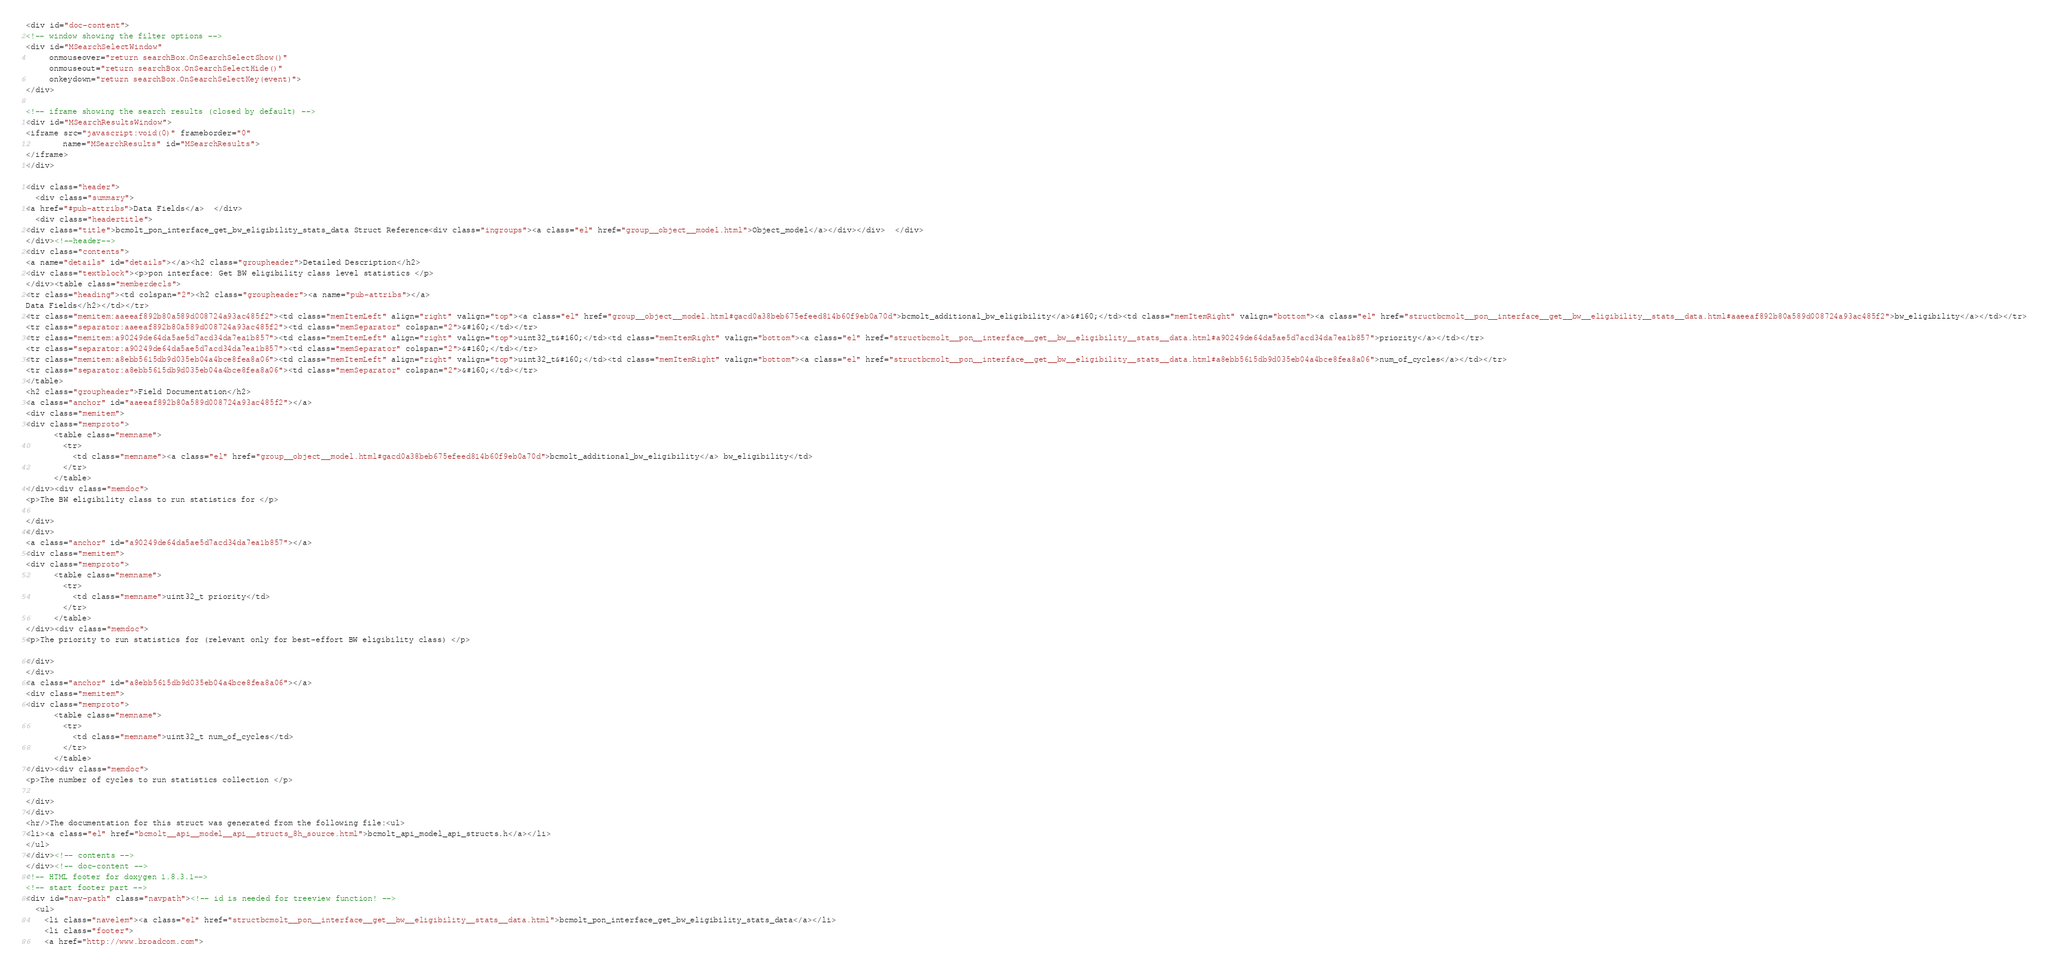<code> <loc_0><loc_0><loc_500><loc_500><_HTML_><div id="doc-content">
<!-- window showing the filter options -->
<div id="MSearchSelectWindow"
     onmouseover="return searchBox.OnSearchSelectShow()"
     onmouseout="return searchBox.OnSearchSelectHide()"
     onkeydown="return searchBox.OnSearchSelectKey(event)">
</div>

<!-- iframe showing the search results (closed by default) -->
<div id="MSearchResultsWindow">
<iframe src="javascript:void(0)" frameborder="0" 
        name="MSearchResults" id="MSearchResults">
</iframe>
</div>

<div class="header">
  <div class="summary">
<a href="#pub-attribs">Data Fields</a>  </div>
  <div class="headertitle">
<div class="title">bcmolt_pon_interface_get_bw_eligibility_stats_data Struct Reference<div class="ingroups"><a class="el" href="group__object__model.html">Object_model</a></div></div>  </div>
</div><!--header-->
<div class="contents">
<a name="details" id="details"></a><h2 class="groupheader">Detailed Description</h2>
<div class="textblock"><p>pon interface: Get BW eligibility class level statistics </p>
</div><table class="memberdecls">
<tr class="heading"><td colspan="2"><h2 class="groupheader"><a name="pub-attribs"></a>
Data Fields</h2></td></tr>
<tr class="memitem:aaeeaf892b80a589d008724a93ac485f2"><td class="memItemLeft" align="right" valign="top"><a class="el" href="group__object__model.html#gacd0a38beb675efeed814b60f9eb0a70d">bcmolt_additional_bw_eligibility</a>&#160;</td><td class="memItemRight" valign="bottom"><a class="el" href="structbcmolt__pon__interface__get__bw__eligibility__stats__data.html#aaeeaf892b80a589d008724a93ac485f2">bw_eligibility</a></td></tr>
<tr class="separator:aaeeaf892b80a589d008724a93ac485f2"><td class="memSeparator" colspan="2">&#160;</td></tr>
<tr class="memitem:a90249de64da5ae5d7acd34da7ea1b857"><td class="memItemLeft" align="right" valign="top">uint32_t&#160;</td><td class="memItemRight" valign="bottom"><a class="el" href="structbcmolt__pon__interface__get__bw__eligibility__stats__data.html#a90249de64da5ae5d7acd34da7ea1b857">priority</a></td></tr>
<tr class="separator:a90249de64da5ae5d7acd34da7ea1b857"><td class="memSeparator" colspan="2">&#160;</td></tr>
<tr class="memitem:a8ebb5615db9d035eb04a4bce8fea8a06"><td class="memItemLeft" align="right" valign="top">uint32_t&#160;</td><td class="memItemRight" valign="bottom"><a class="el" href="structbcmolt__pon__interface__get__bw__eligibility__stats__data.html#a8ebb5615db9d035eb04a4bce8fea8a06">num_of_cycles</a></td></tr>
<tr class="separator:a8ebb5615db9d035eb04a4bce8fea8a06"><td class="memSeparator" colspan="2">&#160;</td></tr>
</table>
<h2 class="groupheader">Field Documentation</h2>
<a class="anchor" id="aaeeaf892b80a589d008724a93ac485f2"></a>
<div class="memitem">
<div class="memproto">
      <table class="memname">
        <tr>
          <td class="memname"><a class="el" href="group__object__model.html#gacd0a38beb675efeed814b60f9eb0a70d">bcmolt_additional_bw_eligibility</a> bw_eligibility</td>
        </tr>
      </table>
</div><div class="memdoc">
<p>The BW eligibility class to run statistics for </p>

</div>
</div>
<a class="anchor" id="a90249de64da5ae5d7acd34da7ea1b857"></a>
<div class="memitem">
<div class="memproto">
      <table class="memname">
        <tr>
          <td class="memname">uint32_t priority</td>
        </tr>
      </table>
</div><div class="memdoc">
<p>The priority to run statistics for (relevant only for best-effort BW eligibility class) </p>

</div>
</div>
<a class="anchor" id="a8ebb5615db9d035eb04a4bce8fea8a06"></a>
<div class="memitem">
<div class="memproto">
      <table class="memname">
        <tr>
          <td class="memname">uint32_t num_of_cycles</td>
        </tr>
      </table>
</div><div class="memdoc">
<p>The number of cycles to run statistics collection </p>

</div>
</div>
<hr/>The documentation for this struct was generated from the following file:<ul>
<li><a class="el" href="bcmolt__api__model__api__structs_8h_source.html">bcmolt_api_model_api_structs.h</a></li>
</ul>
</div><!-- contents -->
</div><!-- doc-content -->
<!-- HTML footer for doxygen 1.8.3.1-->
<!-- start footer part -->
<div id="nav-path" class="navpath"><!-- id is needed for treeview function! -->
  <ul>
    <li class="navelem"><a class="el" href="structbcmolt__pon__interface__get__bw__eligibility__stats__data.html">bcmolt_pon_interface_get_bw_eligibility_stats_data</a></li>
    <li class="footer">
    <a href="http://www.broadcom.com"></code> 